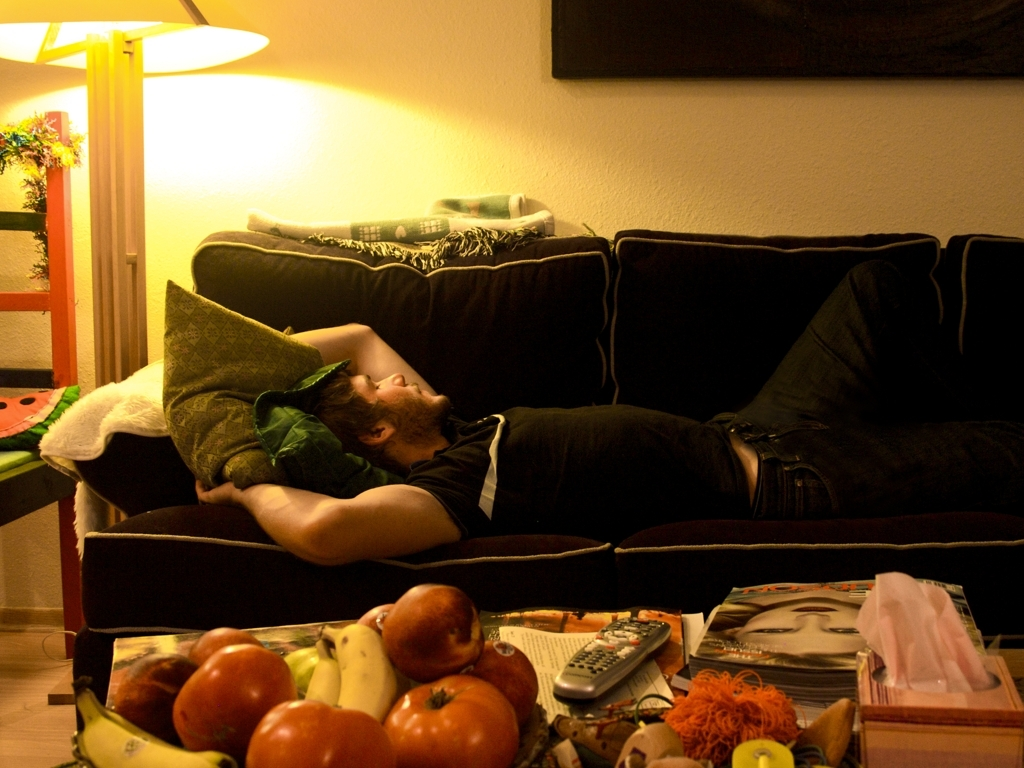What might the person be doing in this image? The individual appears to be taking a rest or a nap on a couch, possibly after a long day, as suggested by the casual and relaxed posture. 